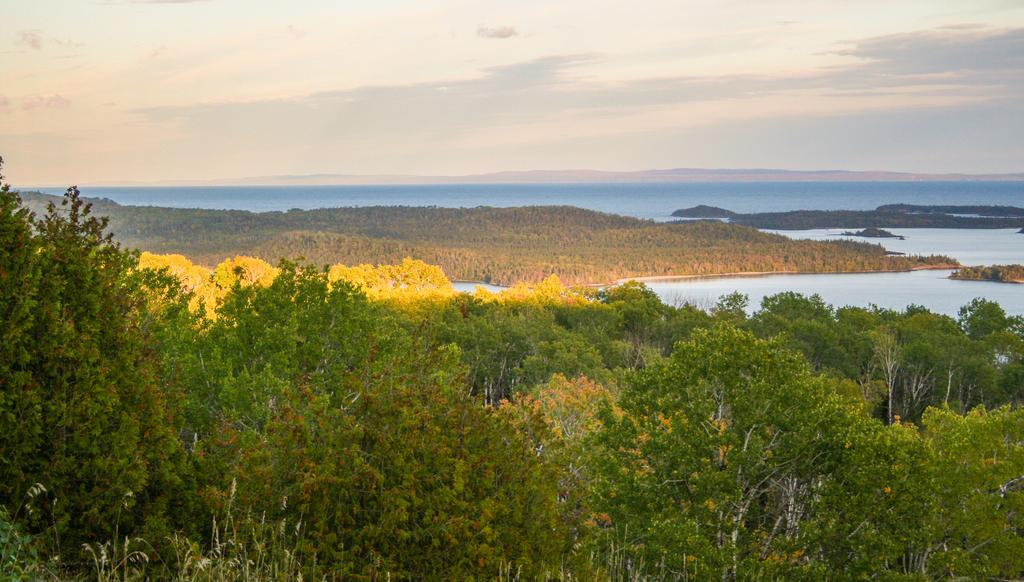What type of vegetation can be seen in the image? There are trees in the image. What colors are the trees in the image? The trees have green and yellow colors. What is visible in the background of the image? There is water, clouds, and the sky visible in the background of the image. What type of poison is being used to spark a trick in the image? There is no poison, spark, or trick present in the image. The image features trees with green and yellow colors, and a background with water, clouds, and the sky. 